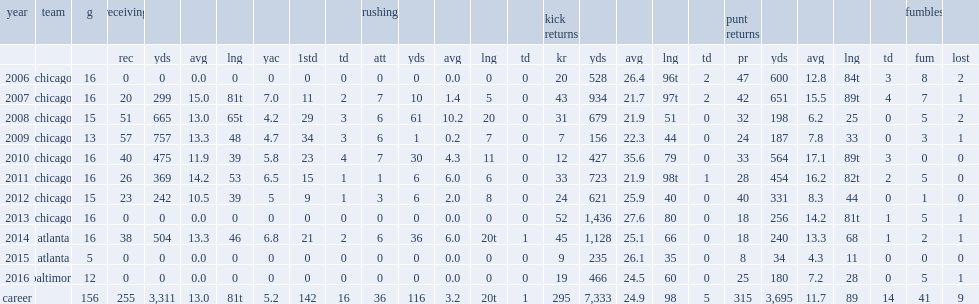How many kick returns did devin hester get in 2006? 20.0. 